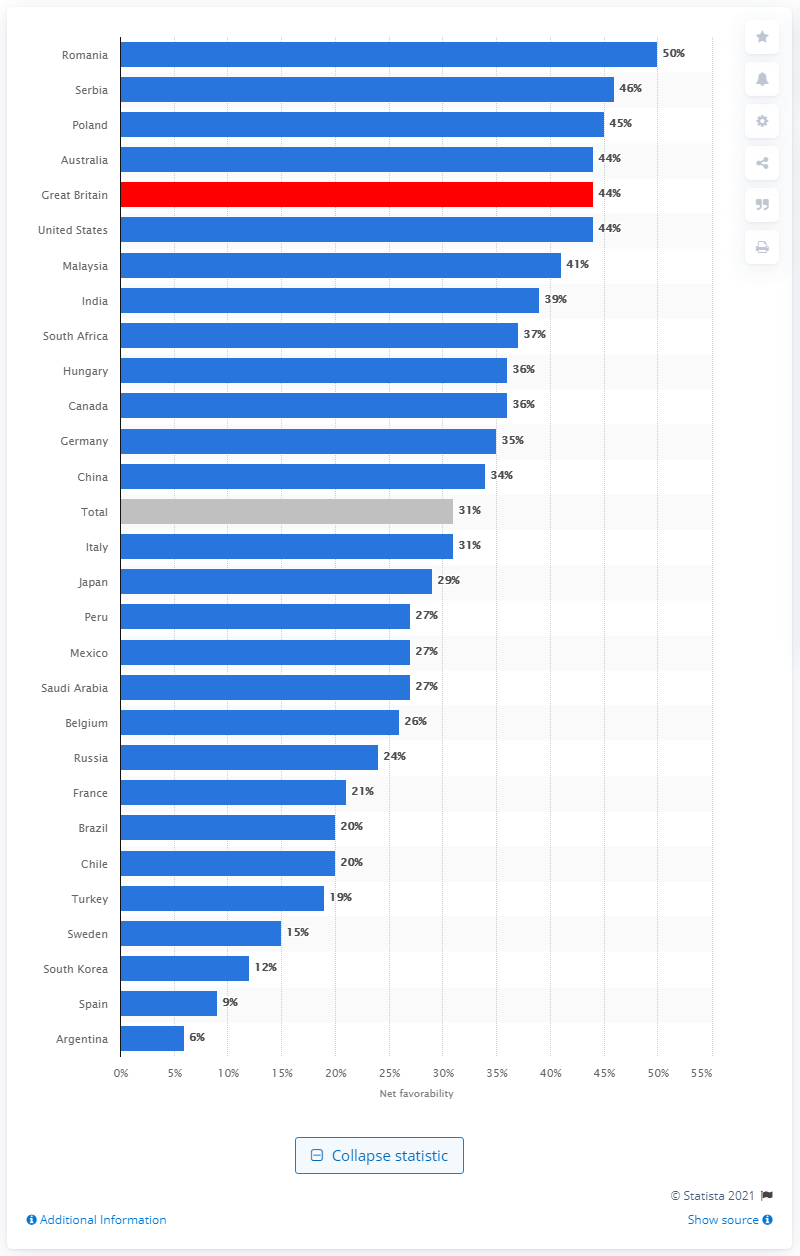Mention a couple of crucial points in this snapshot. It is in Romania where Catherine is most favorably viewed. 